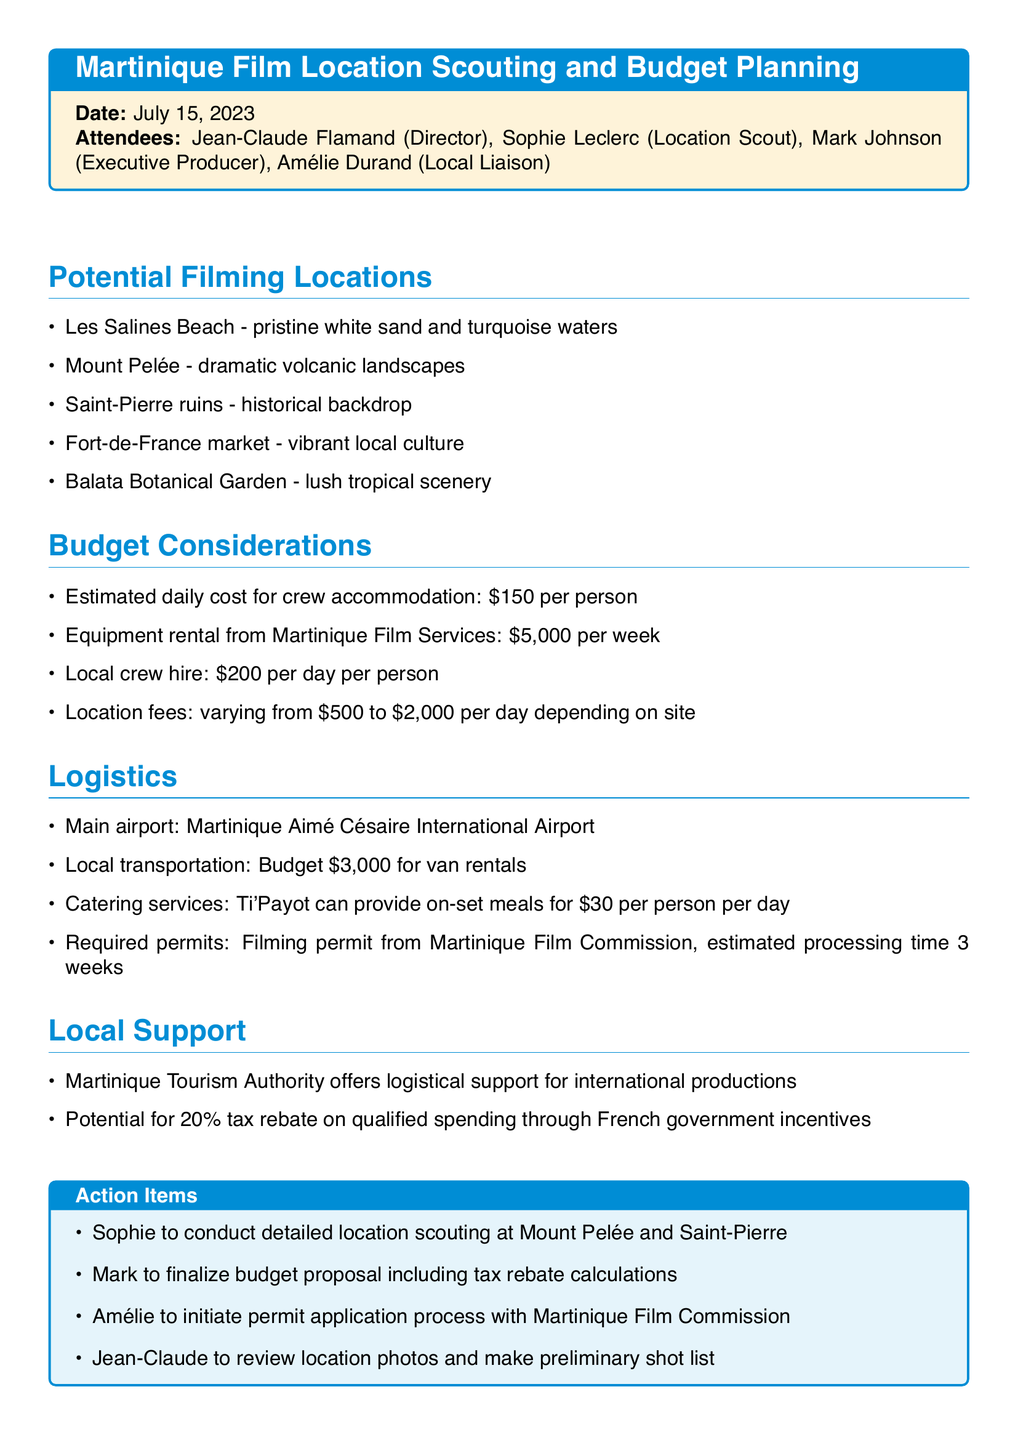What is the meeting date? The meeting date is explicitly mentioned at the beginning of the document.
Answer: July 15, 2023 Who is the local liaison? The local liaison is listed among the attendees of the meeting.
Answer: Amélie Durand What is the estimated daily cost for crew accommodation? The budget considerations section specifies the cost for crew accommodation per day.
Answer: $150 per person How much is the equipment rental per week? The budget details specifically mention the cost of equipment rental per week.
Answer: $5,000 What filming location has historical significance? The potential filming locations include one that is noted for its historical backdrop.
Answer: Saint-Pierre ruins What is the estimated processing time for required permits? The document mentions the estimated time for obtaining filming permits.
Answer: 3 weeks What transportation budget is allocated for van rentals? The logistics section includes a specified budget for local transportation.
Answer: $3,000 Who is responsible for finalizing the budget proposal? The action items specify who will handle the budget proposal.
Answer: Mark Which service can provide catering for on-set meals? The logistics section states who can provide meals for the crew on-set.
Answer: Ti'Payot 